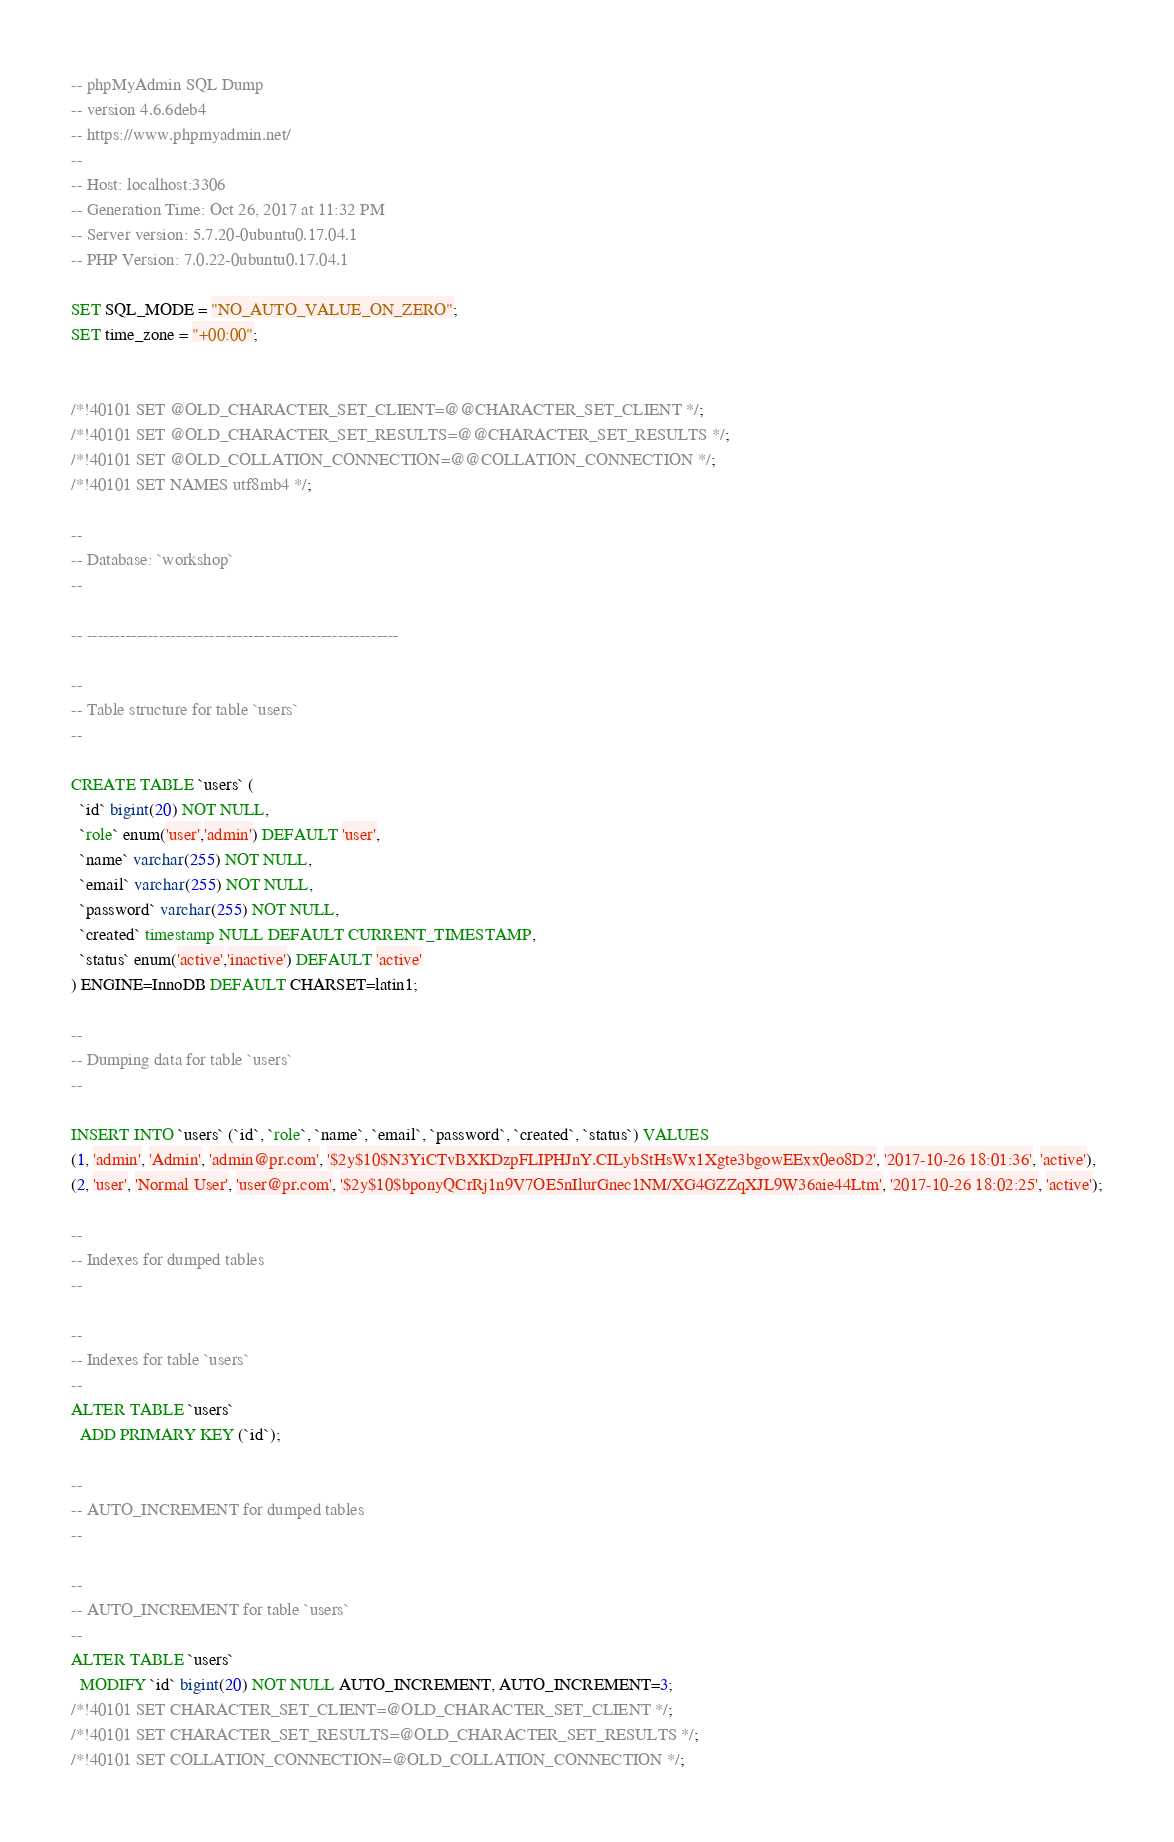<code> <loc_0><loc_0><loc_500><loc_500><_SQL_>-- phpMyAdmin SQL Dump
-- version 4.6.6deb4
-- https://www.phpmyadmin.net/
--
-- Host: localhost:3306
-- Generation Time: Oct 26, 2017 at 11:32 PM
-- Server version: 5.7.20-0ubuntu0.17.04.1
-- PHP Version: 7.0.22-0ubuntu0.17.04.1

SET SQL_MODE = "NO_AUTO_VALUE_ON_ZERO";
SET time_zone = "+00:00";


/*!40101 SET @OLD_CHARACTER_SET_CLIENT=@@CHARACTER_SET_CLIENT */;
/*!40101 SET @OLD_CHARACTER_SET_RESULTS=@@CHARACTER_SET_RESULTS */;
/*!40101 SET @OLD_COLLATION_CONNECTION=@@COLLATION_CONNECTION */;
/*!40101 SET NAMES utf8mb4 */;

--
-- Database: `workshop`
--

-- --------------------------------------------------------

--
-- Table structure for table `users`
--

CREATE TABLE `users` (
  `id` bigint(20) NOT NULL,
  `role` enum('user','admin') DEFAULT 'user',
  `name` varchar(255) NOT NULL,
  `email` varchar(255) NOT NULL,
  `password` varchar(255) NOT NULL,
  `created` timestamp NULL DEFAULT CURRENT_TIMESTAMP,
  `status` enum('active','inactive') DEFAULT 'active'
) ENGINE=InnoDB DEFAULT CHARSET=latin1;

--
-- Dumping data for table `users`
--

INSERT INTO `users` (`id`, `role`, `name`, `email`, `password`, `created`, `status`) VALUES
(1, 'admin', 'Admin', 'admin@pr.com', '$2y$10$N3YiCTvBXKDzpFLIPHJnY.CILybStHsWx1Xgte3bgowEExx0eo8D2', '2017-10-26 18:01:36', 'active'),
(2, 'user', 'Normal User', 'user@pr.com', '$2y$10$bponyQCrRj1n9V7OE5nIlurGnec1NM/XG4GZZqXJL9W36aie44Ltm', '2017-10-26 18:02:25', 'active');

--
-- Indexes for dumped tables
--

--
-- Indexes for table `users`
--
ALTER TABLE `users`
  ADD PRIMARY KEY (`id`);

--
-- AUTO_INCREMENT for dumped tables
--

--
-- AUTO_INCREMENT for table `users`
--
ALTER TABLE `users`
  MODIFY `id` bigint(20) NOT NULL AUTO_INCREMENT, AUTO_INCREMENT=3;
/*!40101 SET CHARACTER_SET_CLIENT=@OLD_CHARACTER_SET_CLIENT */;
/*!40101 SET CHARACTER_SET_RESULTS=@OLD_CHARACTER_SET_RESULTS */;
/*!40101 SET COLLATION_CONNECTION=@OLD_COLLATION_CONNECTION */;
</code> 